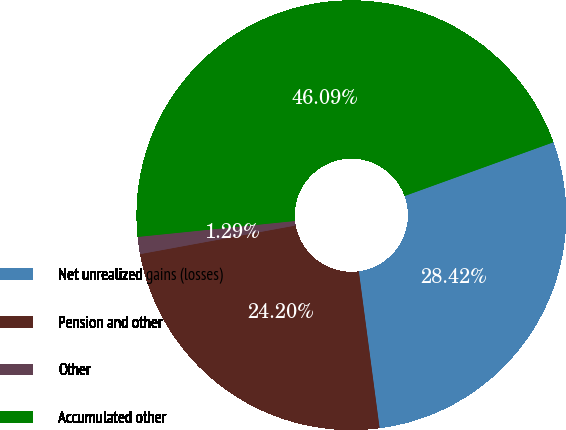<chart> <loc_0><loc_0><loc_500><loc_500><pie_chart><fcel>Net unrealized gains (losses)<fcel>Pension and other<fcel>Other<fcel>Accumulated other<nl><fcel>28.42%<fcel>24.2%<fcel>1.29%<fcel>46.09%<nl></chart> 